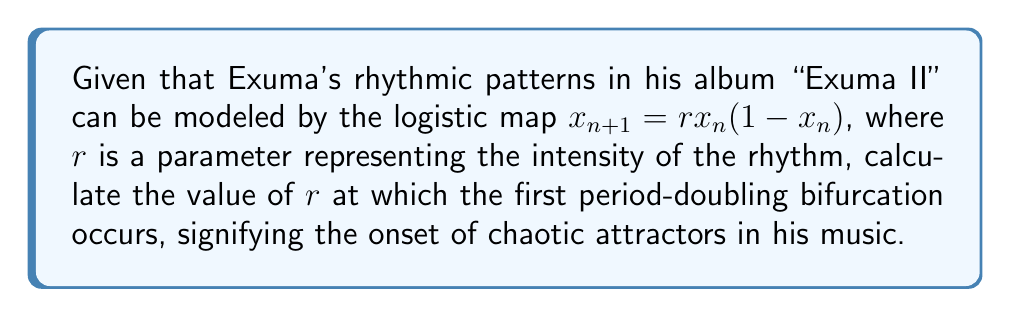Can you answer this question? To solve this problem, we need to follow these steps:

1) The logistic map $x_{n+1} = rx_n(1-x_n)$ is a classic example of a system that can exhibit chaotic behavior.

2) The first period-doubling bifurcation occurs when the fixed point of the system becomes unstable and splits into a period-2 cycle.

3) To find the fixed point, we solve the equation:
   $x = rx(1-x)$
   
4) This can be rewritten as:
   $x = rx - rx^2$
   $0 = rx - rx^2 - x$
   $0 = x(r - rx - 1)$

5) The non-zero solution is when $r - rx - 1 = 0$, or $x = 1 - \frac{1}{r}$

6) The stability of this fixed point changes when the derivative of the map at this point equals -1:
   $\frac{d}{dx}(rx(1-x)) = r(1-2x) = -1$

7) Substituting the fixed point value:
   $r(1-2(1-\frac{1}{r})) = -1$
   $r(1-2+\frac{2}{r}) = -1$
   $r(-1+\frac{2}{r}) = -1$
   $-r+2 = -1$
   $r = 3$

Therefore, the first period-doubling bifurcation, signifying the onset of chaotic attractors in Exuma's rhythmic patterns, occurs when $r = 3$.
Answer: $r = 3$ 